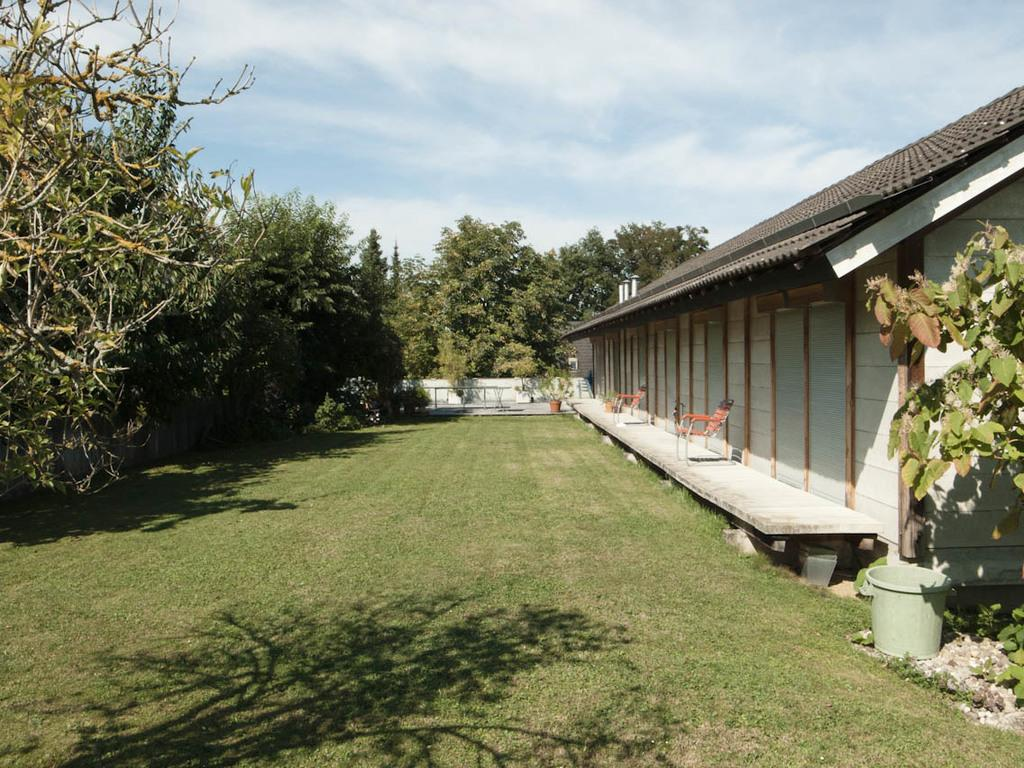What type of structure is visible in the image? There is a house in the image. What natural elements can be seen in the image? There are trees, plants, and grass visible in the image. What type of furniture is present in the image? There are chairs on the floor in the image. What type of thread is being used to hold the house together in the image? There is no thread visible in the image, and the house appears to be a solid structure. 